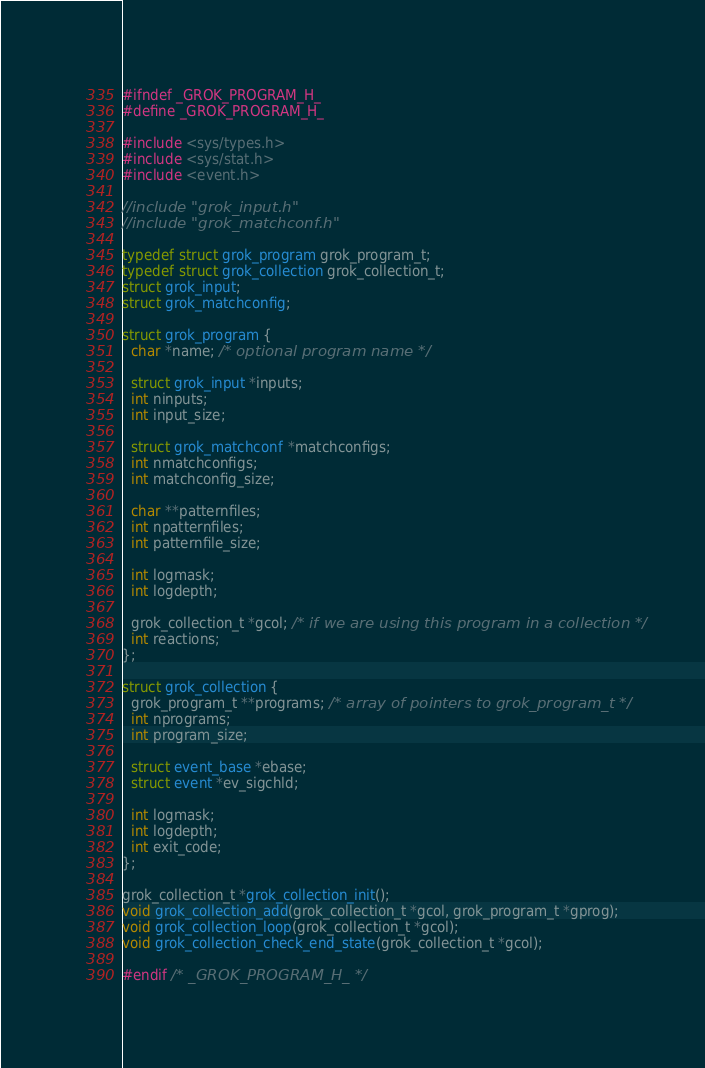Convert code to text. <code><loc_0><loc_0><loc_500><loc_500><_C_>#ifndef _GROK_PROGRAM_H_
#define _GROK_PROGRAM_H_

#include <sys/types.h>
#include <sys/stat.h>
#include <event.h>

//include "grok_input.h"
//include "grok_matchconf.h"

typedef struct grok_program grok_program_t;
typedef struct grok_collection grok_collection_t;
struct grok_input;
struct grok_matchconfig;

struct grok_program {
  char *name; /* optional program name */

  struct grok_input *inputs;
  int ninputs;
  int input_size;

  struct grok_matchconf *matchconfigs;
  int nmatchconfigs;
  int matchconfig_size;

  char **patternfiles;
  int npatternfiles;
  int patternfile_size;

  int logmask;
  int logdepth;

  grok_collection_t *gcol; /* if we are using this program in a collection */
  int reactions;
};

struct grok_collection {
  grok_program_t **programs; /* array of pointers to grok_program_t */
  int nprograms;
  int program_size;

  struct event_base *ebase;
  struct event *ev_sigchld;

  int logmask;
  int logdepth;
  int exit_code;
};

grok_collection_t *grok_collection_init();
void grok_collection_add(grok_collection_t *gcol, grok_program_t *gprog);
void grok_collection_loop(grok_collection_t *gcol);
void grok_collection_check_end_state(grok_collection_t *gcol);

#endif /* _GROK_PROGRAM_H_ */
</code> 